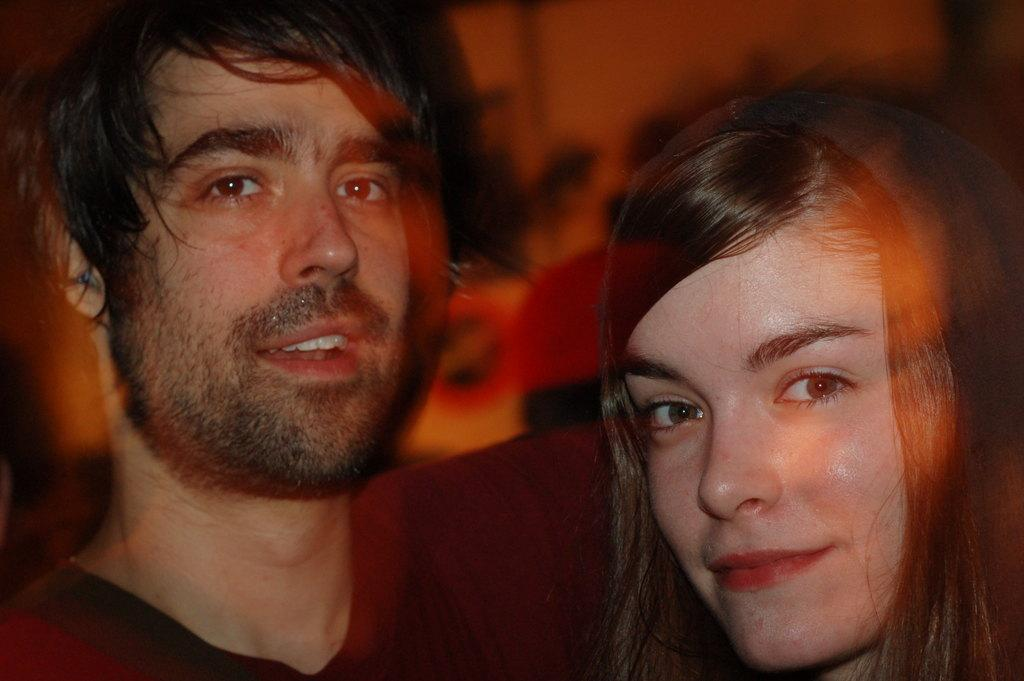Who are the people in the image? There is a man and a woman in the image. What are the expressions on their faces? Both the man and woman are smiling in the image. Can you describe the background of the image? The background of the image is blurry. What type of can is visible in the image? There is no can present in the image. What substance is being poured from the kettle in the image? There is no kettle or substance being poured in the image. 